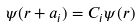<formula> <loc_0><loc_0><loc_500><loc_500>\psi ( r + a _ { i } ) = C _ { i } \psi ( r )</formula> 